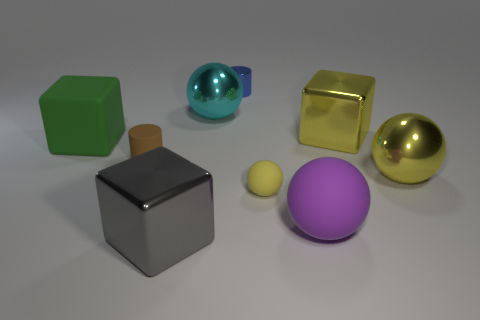Subtract all brown cubes. Subtract all gray cylinders. How many cubes are left? 3 Add 1 big red cylinders. How many objects exist? 10 Subtract all cubes. How many objects are left? 6 Add 6 large green blocks. How many large green blocks exist? 7 Subtract 0 brown cubes. How many objects are left? 9 Subtract all large blocks. Subtract all large shiny blocks. How many objects are left? 4 Add 6 blue objects. How many blue objects are left? 7 